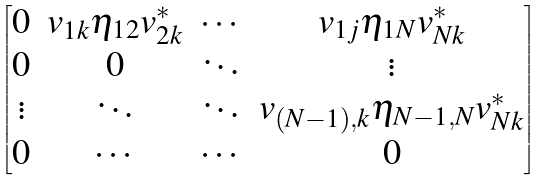Convert formula to latex. <formula><loc_0><loc_0><loc_500><loc_500>\begin{bmatrix} 0 & v _ { 1 k } \eta _ { 1 2 } v _ { 2 k } ^ { * } & \cdots & v _ { 1 j } \eta _ { 1 N } v _ { N k } ^ { * } \\ 0 & 0 & \ddots & \vdots \\ \vdots & \ddots & \ddots & v _ { ( N - 1 ) , k } \eta _ { N - 1 , N } v _ { N k } ^ { * } \\ 0 & \cdots & \cdots & 0 \\ \end{bmatrix}</formula> 